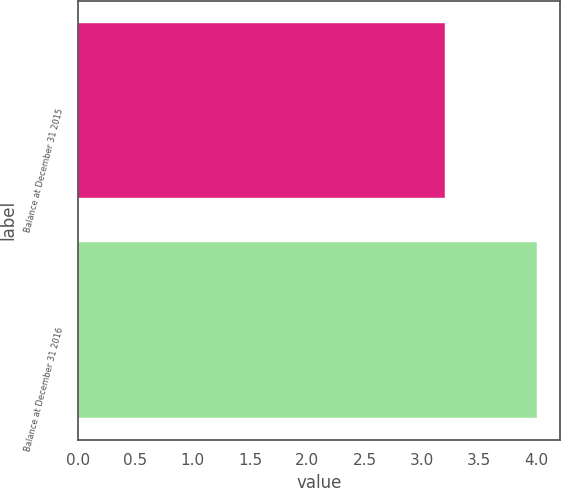Convert chart. <chart><loc_0><loc_0><loc_500><loc_500><bar_chart><fcel>Balance at December 31 2015<fcel>Balance at December 31 2016<nl><fcel>3.2<fcel>4<nl></chart> 